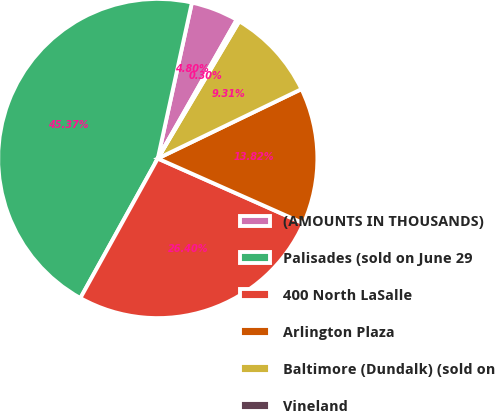Convert chart to OTSL. <chart><loc_0><loc_0><loc_500><loc_500><pie_chart><fcel>(AMOUNTS IN THOUSANDS)<fcel>Palisades (sold on June 29<fcel>400 North LaSalle<fcel>Arlington Plaza<fcel>Baltimore (Dundalk) (sold on<fcel>Vineland<nl><fcel>4.8%<fcel>45.37%<fcel>26.4%<fcel>13.82%<fcel>9.31%<fcel>0.3%<nl></chart> 